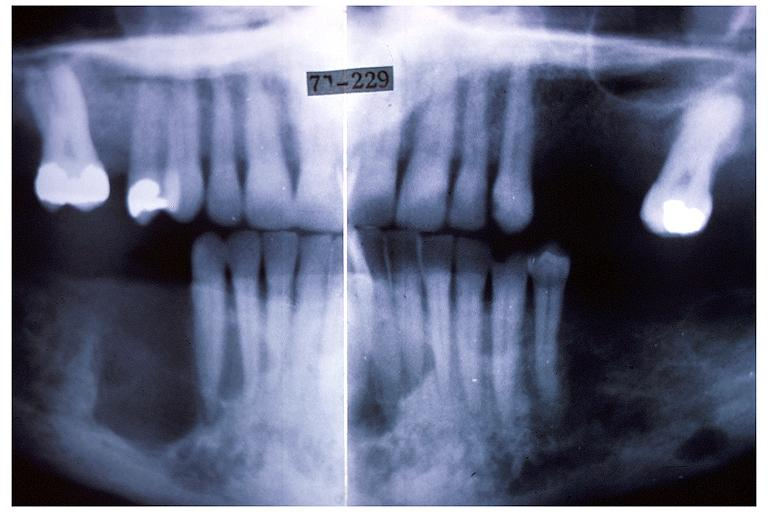what is present?
Answer the question using a single word or phrase. Oral 